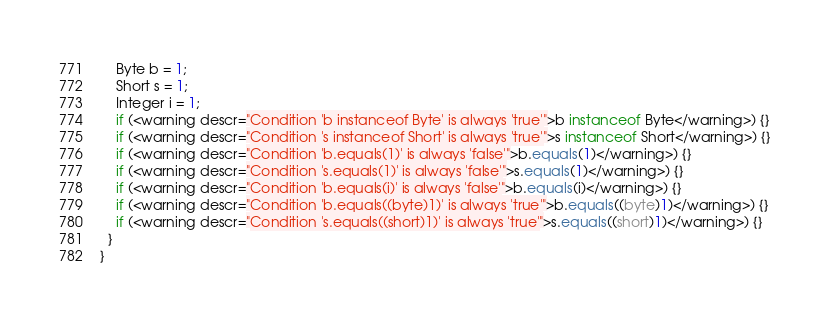<code> <loc_0><loc_0><loc_500><loc_500><_Java_>    Byte b = 1;
    Short s = 1;
    Integer i = 1;
    if (<warning descr="Condition 'b instanceof Byte' is always 'true'">b instanceof Byte</warning>) {}
    if (<warning descr="Condition 's instanceof Short' is always 'true'">s instanceof Short</warning>) {}
    if (<warning descr="Condition 'b.equals(1)' is always 'false'">b.equals(1)</warning>) {}
    if (<warning descr="Condition 's.equals(1)' is always 'false'">s.equals(1)</warning>) {}
    if (<warning descr="Condition 'b.equals(i)' is always 'false'">b.equals(i)</warning>) {}
    if (<warning descr="Condition 'b.equals((byte)1)' is always 'true'">b.equals((byte)1)</warning>) {}
    if (<warning descr="Condition 's.equals((short)1)' is always 'true'">s.equals((short)1)</warning>) {}
  }
}</code> 